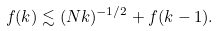Convert formula to latex. <formula><loc_0><loc_0><loc_500><loc_500>f ( k ) \lesssim ( N k ) ^ { - 1 / 2 } + f ( k - 1 ) .</formula> 